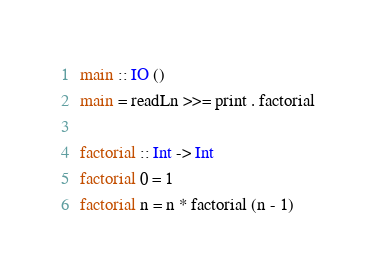<code> <loc_0><loc_0><loc_500><loc_500><_Haskell_>main :: IO ()
main = readLn >>= print . factorial

factorial :: Int -> Int
factorial 0 = 1
factorial n = n * factorial (n - 1)</code> 